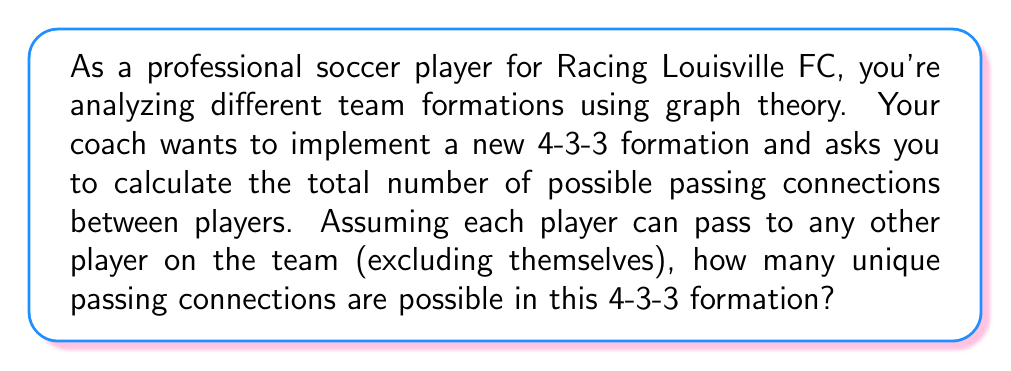Show me your answer to this math problem. To solve this problem, we can use graph theory concepts:

1. In a 4-3-3 formation, there are 10 outfield players (excluding the goalkeeper).

2. We can represent each player as a vertex in a graph, and each possible pass as an edge connecting two vertices.

3. This scenario creates a complete graph, where every vertex is connected to every other vertex (except itself).

4. The number of edges in a complete graph with $n$ vertices is given by the formula:

   $$E = \frac{n(n-1)}{2}$$

   Where $E$ is the number of edges (passing connections) and $n$ is the number of vertices (players).

5. In this case, $n = 10$ (10 outfield players).

6. Plugging in the values:

   $$E = \frac{10(10-1)}{2} = \frac{10 \times 9}{2} = \frac{90}{2} = 45$$

Therefore, there are 45 unique passing connections possible in the 4-3-3 formation.

This analysis helps in understanding the complexity of the team's passing network and can be used to optimize strategies for ball movement and player positioning.
Answer: 45 unique passing connections 